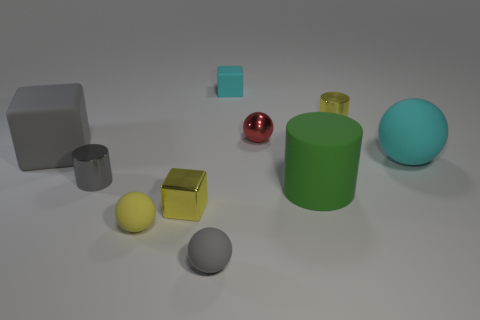What can you infer about the setting of these objects? The objects are placed on what appears to be a smooth, matte surface, perhaps a table or a solid ground within an indoor setting. The evenly diffused lighting and shadow placement suggests that the lighting source is broad and possibly overhead. These factors, combined with the lack of background objects or scenery, indicate that this setting might be a controlled environment, designed for a display or study of these objects. 